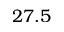<formula> <loc_0><loc_0><loc_500><loc_500>2 7 . 5</formula> 